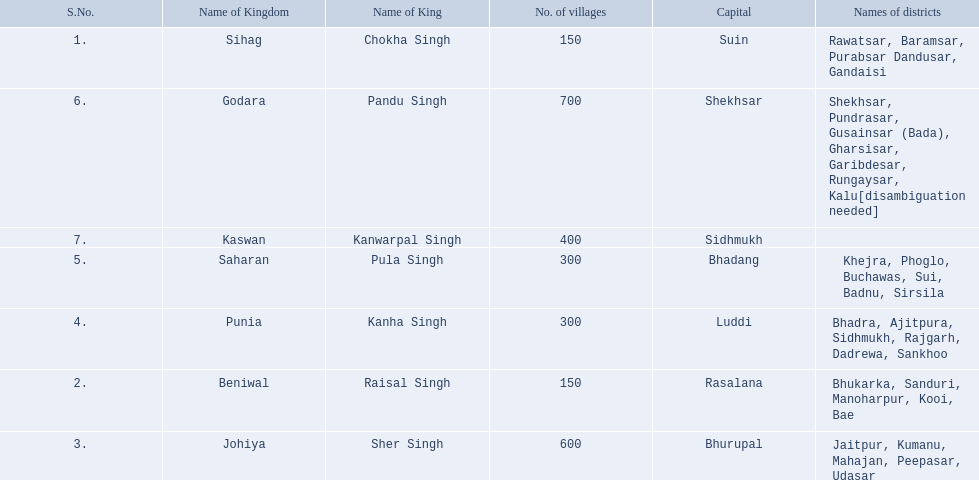Can you parse all the data within this table? {'header': ['S.No.', 'Name of Kingdom', 'Name of King', 'No. of villages', 'Capital', 'Names of districts'], 'rows': [['1.', 'Sihag', 'Chokha Singh', '150', 'Suin', 'Rawatsar, Baramsar, Purabsar Dandusar, Gandaisi'], ['6.', 'Godara', 'Pandu Singh', '700', 'Shekhsar', 'Shekhsar, Pundrasar, Gusainsar (Bada), Gharsisar, Garibdesar, Rungaysar, Kalu[disambiguation needed]'], ['7.', 'Kaswan', 'Kanwarpal Singh', '400', 'Sidhmukh', ''], ['5.', 'Saharan', 'Pula Singh', '300', 'Bhadang', 'Khejra, Phoglo, Buchawas, Sui, Badnu, Sirsila'], ['4.', 'Punia', 'Kanha Singh', '300', 'Luddi', 'Bhadra, Ajitpura, Sidhmukh, Rajgarh, Dadrewa, Sankhoo'], ['2.', 'Beniwal', 'Raisal Singh', '150', 'Rasalana', 'Bhukarka, Sanduri, Manoharpur, Kooi, Bae'], ['3.', 'Johiya', 'Sher Singh', '600', 'Bhurupal', 'Jaitpur, Kumanu, Mahajan, Peepasar, Udasar']]} Which kingdom contained the least amount of villages along with sihag? Beniwal. Which kingdom contained the most villages? Godara. Which village was tied at second most villages with godara? Johiya. 